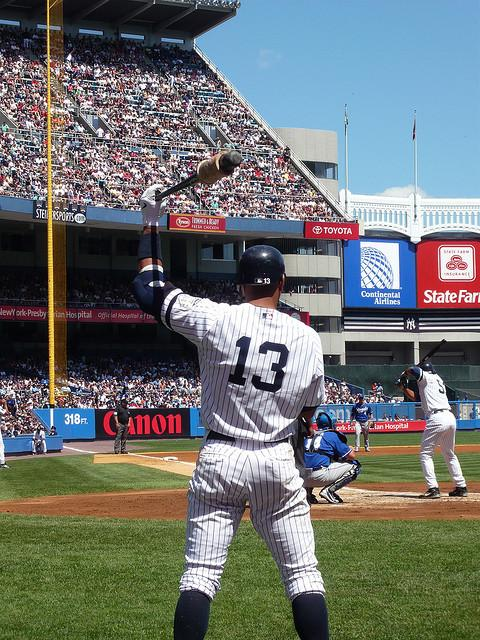What is the thing on the baseball bat for?

Choices:
A) warming up
B) cheating
C) just aesthetics
D) making noise warming up 